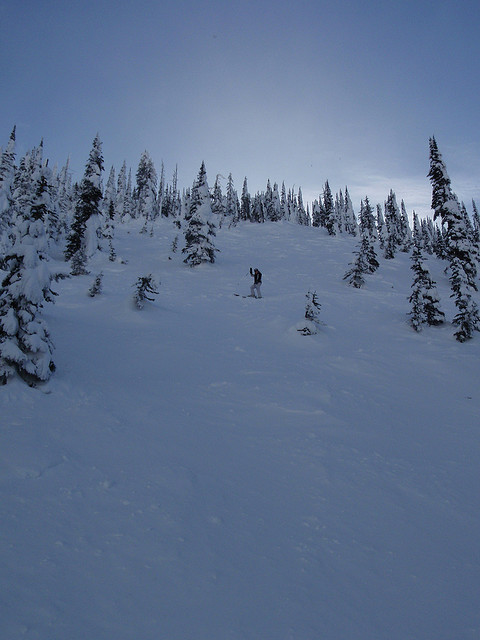What preparations should one make before embarking on a snowboarding trip in this type of terrain? Preparing for a snowboarding trip in such terrain involves packing essential gear like an avalanche safety kit, including a beacon, probe, and shovel. It's also crucial to check the weather and avalanche forecasts, carry sufficient hydration and nutrition, and inform someone about your travel plans for safety. 